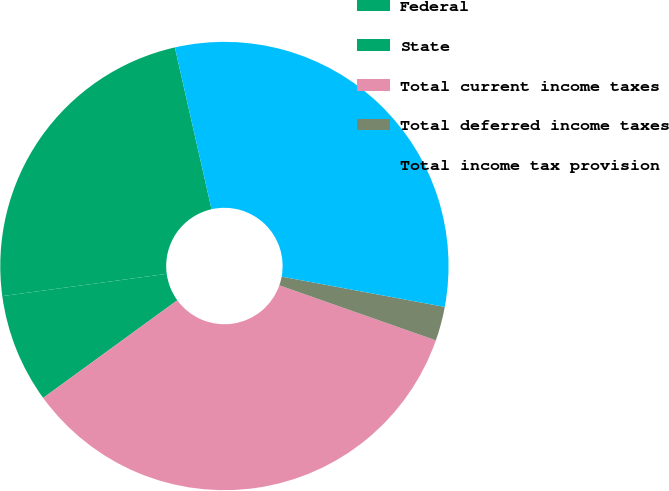Convert chart. <chart><loc_0><loc_0><loc_500><loc_500><pie_chart><fcel>Federal<fcel>State<fcel>Total current income taxes<fcel>Total deferred income taxes<fcel>Total income tax provision<nl><fcel>23.6%<fcel>7.87%<fcel>34.61%<fcel>2.46%<fcel>31.47%<nl></chart> 